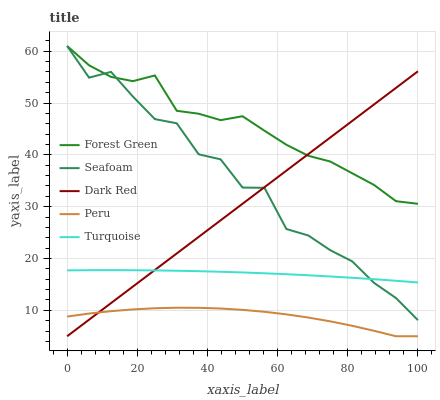Does Peru have the minimum area under the curve?
Answer yes or no. Yes. Does Forest Green have the maximum area under the curve?
Answer yes or no. Yes. Does Turquoise have the minimum area under the curve?
Answer yes or no. No. Does Turquoise have the maximum area under the curve?
Answer yes or no. No. Is Dark Red the smoothest?
Answer yes or no. Yes. Is Seafoam the roughest?
Answer yes or no. Yes. Is Forest Green the smoothest?
Answer yes or no. No. Is Forest Green the roughest?
Answer yes or no. No. Does Dark Red have the lowest value?
Answer yes or no. Yes. Does Turquoise have the lowest value?
Answer yes or no. No. Does Seafoam have the highest value?
Answer yes or no. Yes. Does Turquoise have the highest value?
Answer yes or no. No. Is Peru less than Forest Green?
Answer yes or no. Yes. Is Forest Green greater than Turquoise?
Answer yes or no. Yes. Does Dark Red intersect Peru?
Answer yes or no. Yes. Is Dark Red less than Peru?
Answer yes or no. No. Is Dark Red greater than Peru?
Answer yes or no. No. Does Peru intersect Forest Green?
Answer yes or no. No. 